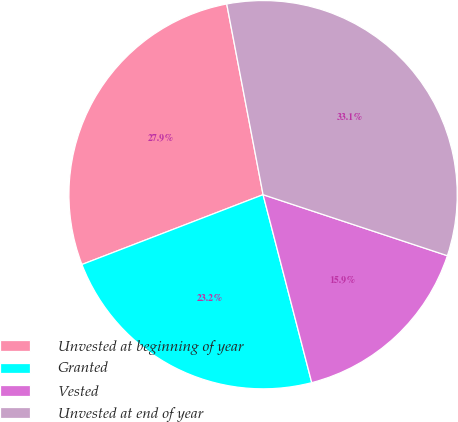Convert chart to OTSL. <chart><loc_0><loc_0><loc_500><loc_500><pie_chart><fcel>Unvested at beginning of year<fcel>Granted<fcel>Vested<fcel>Unvested at end of year<nl><fcel>27.86%<fcel>23.18%<fcel>15.88%<fcel>33.09%<nl></chart> 